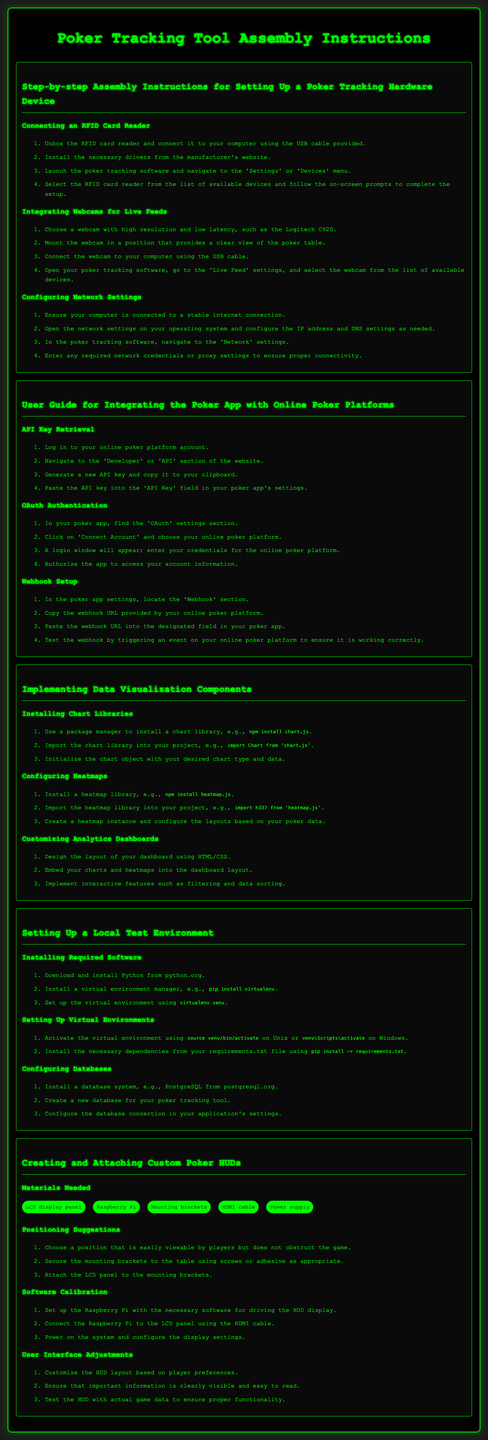What should you connect the RFID card reader with? The RFID card reader should be connected to your computer using the USB cable provided.
Answer: USB cable What is the required webcam model mentioned? The document recommends using a webcam with high resolution and low latency, specifically the Logitech C920.
Answer: Logitech C920 How do you activate the virtual environment in Unix? The instructions specify to activate the virtual environment using the command provided for Unix.
Answer: source venv/bin/activate What library should be installed for data visualization? A chart library such as Chart.js is suggested for data visualization.
Answer: Chart.js How many materials are listed for creating custom poker HUDs? The document lists five items in the "Materials Needed" section for creating and attaching custom poker HUDs.
Answer: Five Where can you retrieve the API key? The API key can be retrieved in the 'Developer' or 'API' section of the online poker platform website.
Answer: Developer section What is the first step in configuring network settings? The first step is to ensure your computer is connected to a stable internet connection.
Answer: Stable internet connection What should you do after generating a new API key? After generating the API key, the next step is to copy it to your clipboard.
Answer: Copy to clipboard How should the HUD layout be customized? The HUD layout should be customized based on player preferences.
Answer: Player preferences 